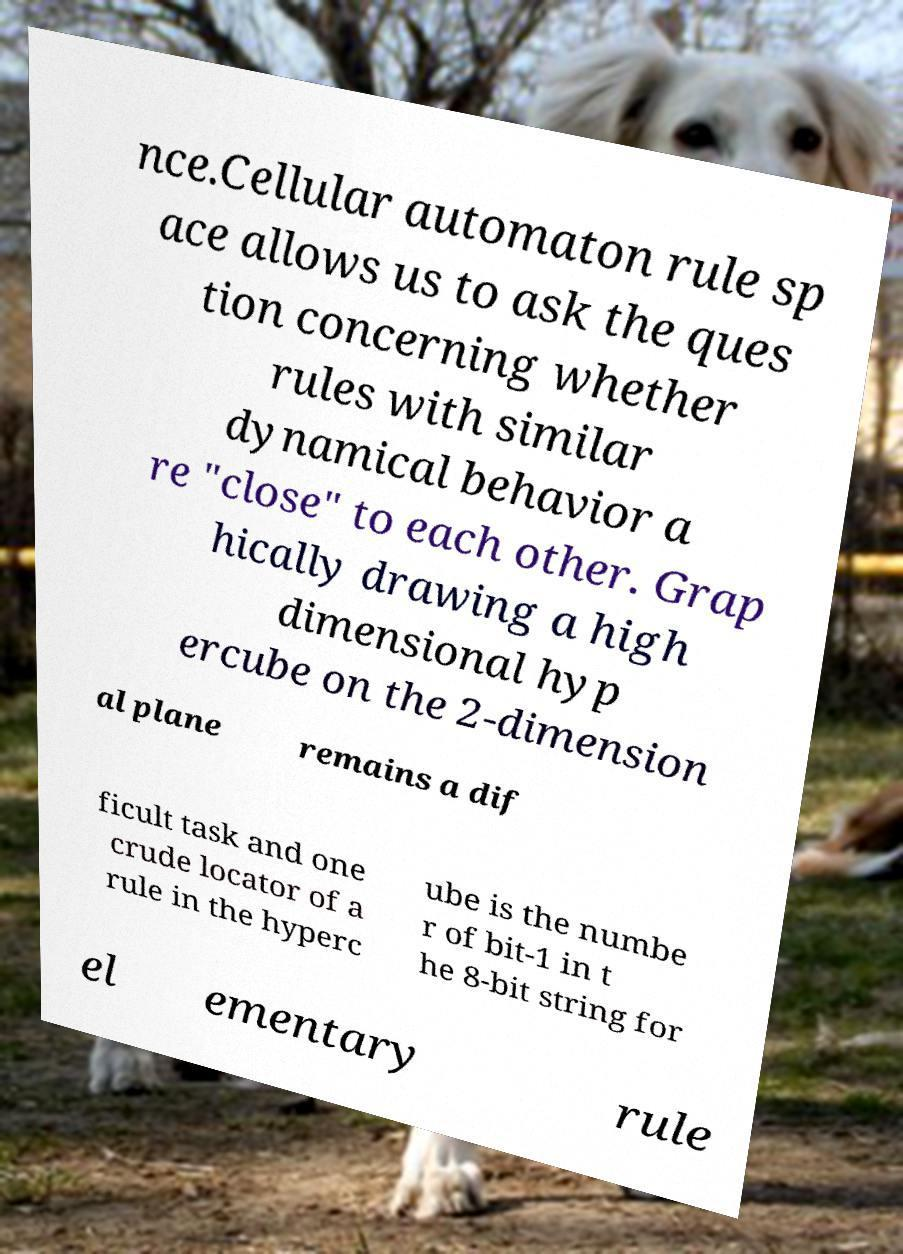Could you extract and type out the text from this image? nce.Cellular automaton rule sp ace allows us to ask the ques tion concerning whether rules with similar dynamical behavior a re "close" to each other. Grap hically drawing a high dimensional hyp ercube on the 2-dimension al plane remains a dif ficult task and one crude locator of a rule in the hyperc ube is the numbe r of bit-1 in t he 8-bit string for el ementary rule 